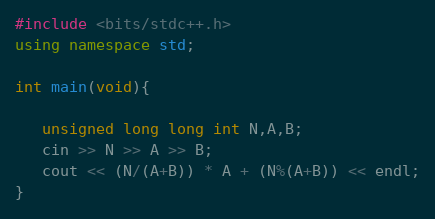<code> <loc_0><loc_0><loc_500><loc_500><_C++_>#include <bits/stdc++.h>
using namespace std;

int main(void){
   
   unsigned long long int N,A,B;
   cin >> N >> A >> B;
   cout << (N/(A+B)) * A + (N%(A+B)) << endl;
}</code> 